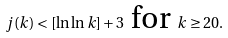Convert formula to latex. <formula><loc_0><loc_0><loc_500><loc_500>j ( k ) < [ \ln \ln k ] + 3 { \text {\ for\ } } k \geq 2 0 .</formula> 